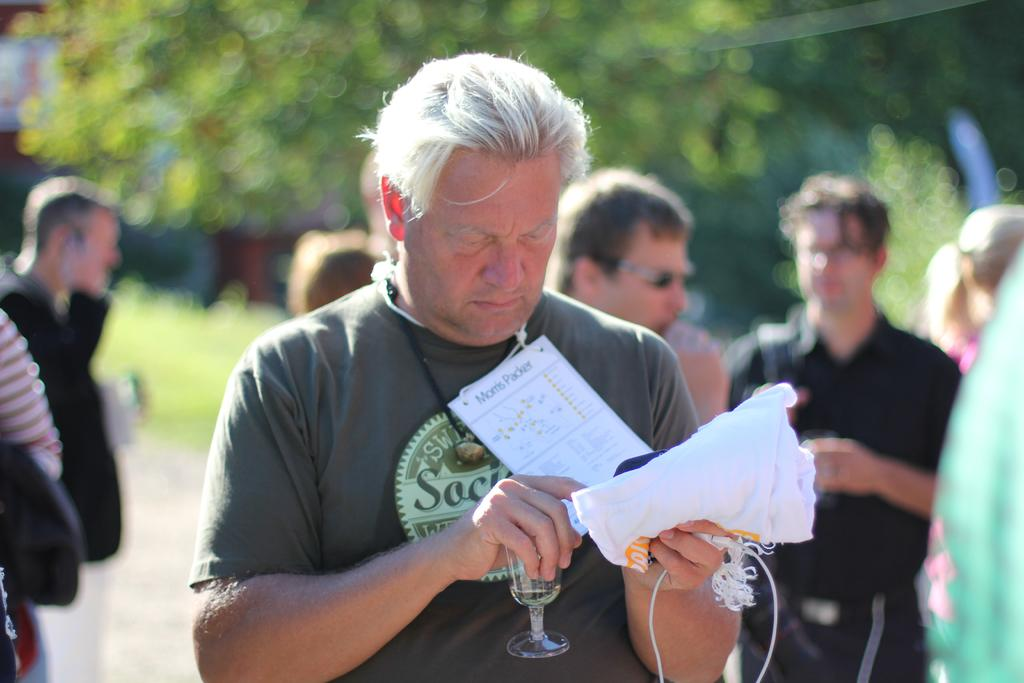What is the person in the foreground of the image holding? The person is holding papers in the image. Can you describe the people in the background of the image? There are other people in the background of the image. What type of vegetation can be seen in the background of the image? There are trees with green color in the background of the image. What type of rifle is the person holding in the image? There is no rifle present in the image; the person is holding papers. Can you describe the goldfish swimming in the background of the image? There are no goldfish present in the image; the background features trees with green color. 